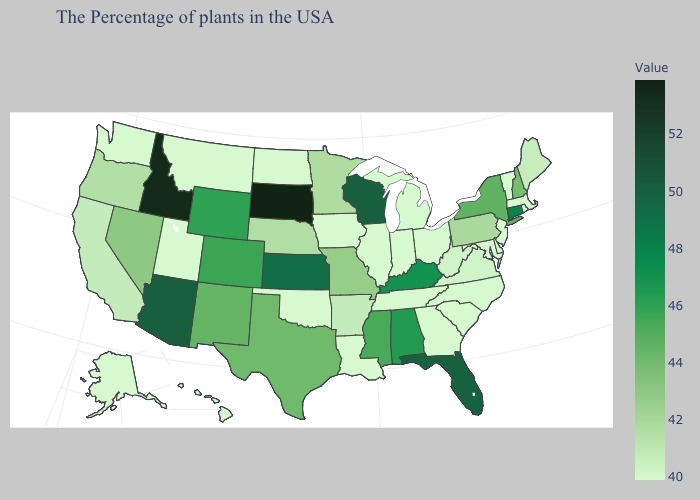Among the states that border Pennsylvania , which have the lowest value?
Answer briefly. New Jersey, Delaware, Maryland, Ohio. Which states hav the highest value in the Northeast?
Short answer required. Connecticut. Among the states that border Utah , which have the highest value?
Answer briefly. Idaho. Is the legend a continuous bar?
Short answer required. Yes. Among the states that border Connecticut , which have the highest value?
Concise answer only. New York. 